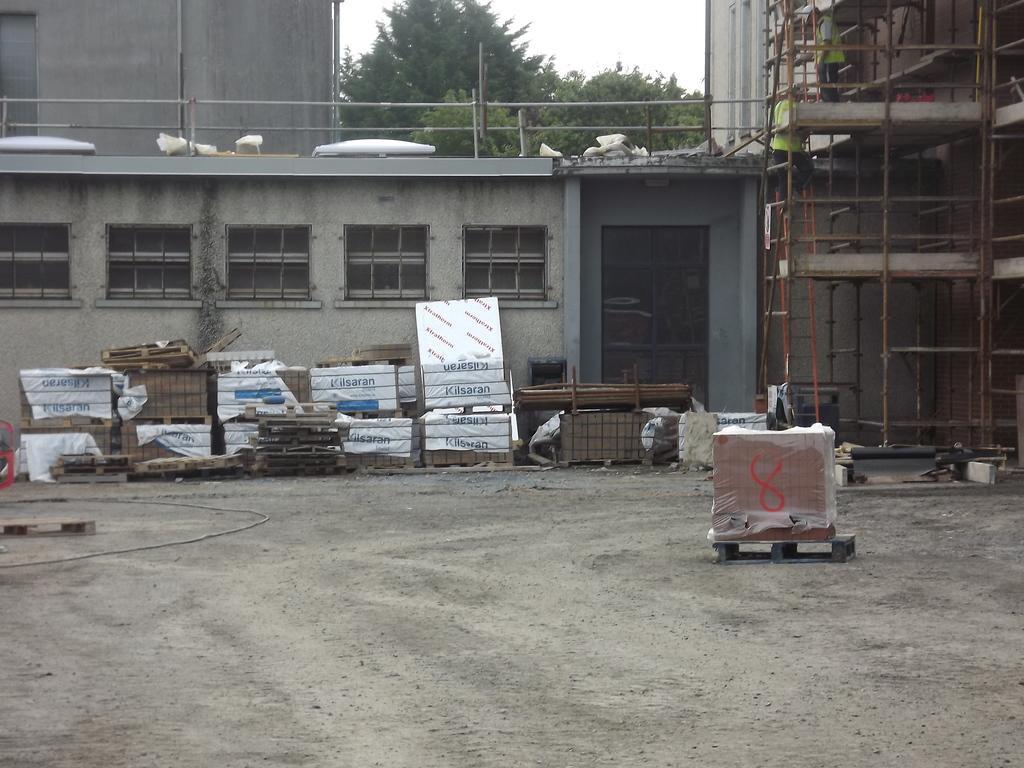Describe this image in one or two sentences. This image is taken outdoors. At the bottom of the image there is a ground. At the top of the image there is the sky. In the middle of the image there is a building with walls, windows, a door and a railing. There are a few wooden sticks. A man is standing on the floor. There are many cardboard boxes on the floor. 